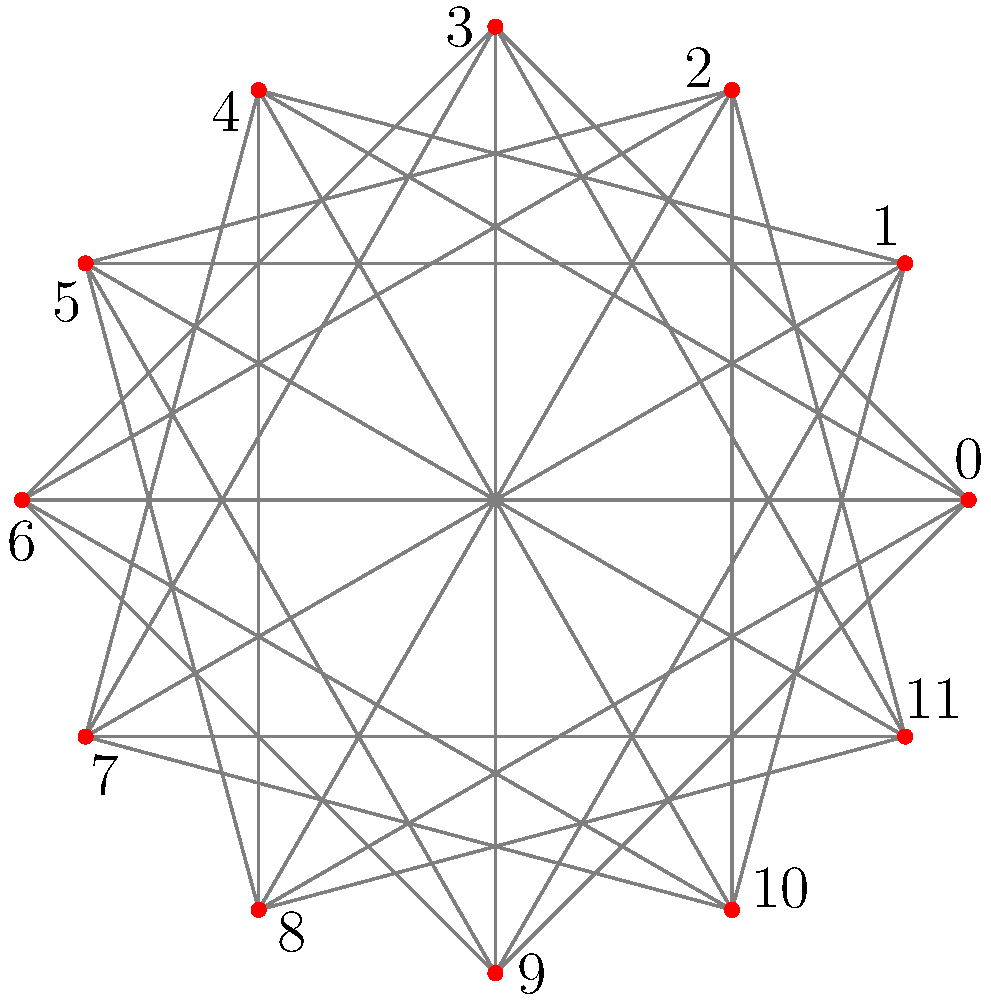In the circular graph representing harmonic relationships between notes on the erhu, each node represents a semitone in the 12-tone scale. Edges connect notes that are either a minor third (3 semitones) or a major third (4 semitones) apart. How many distinct triangles are formed in this graph? Let's approach this step-by-step:

1) First, we need to understand what constitutes a triangle in this graph. A triangle will be formed when three notes are all connected to each other by either minor thirds or major thirds.

2) In the 12-tone scale, we can find these triangles:
   - Minor third triangles: (0,3,6), (1,4,7), (2,5,8), (3,6,9), (4,7,10), (5,8,11)
   - Major third triangles: (0,4,8), (1,5,9), (2,6,10), (3,7,11)

3) Let's count them:
   - There are 6 minor third triangles
   - There are 4 major third triangles

4) In total, we have 6 + 4 = 10 distinct triangles.

Note: Each triangle is counted only once, regardless of the direction or starting point. For example, (0,3,6), (3,6,0), and (6,0,3) are considered the same triangle.
Answer: 10 triangles 